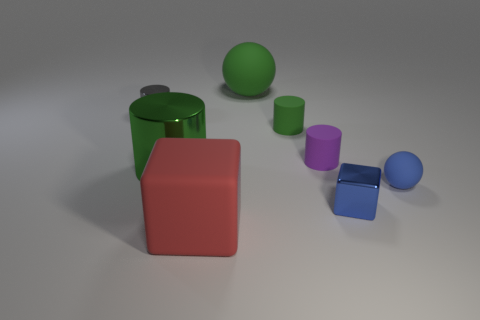Is there any other thing that has the same size as the purple rubber cylinder?
Offer a terse response. Yes. What number of gray objects are tiny metal objects or large cubes?
Make the answer very short. 1. How many green balls are the same size as the green metallic cylinder?
Offer a very short reply. 1. What is the shape of the tiny thing that is the same color as the large metal cylinder?
Provide a succinct answer. Cylinder. What number of objects are small blue rubber cubes or tiny objects on the right side of the big red thing?
Make the answer very short. 4. There is a block that is on the right side of the large green rubber thing; does it have the same size as the ball behind the tiny sphere?
Offer a terse response. No. How many small metallic objects have the same shape as the large shiny object?
Offer a very short reply. 1. The big object that is made of the same material as the tiny gray object is what shape?
Make the answer very short. Cylinder. The small blue thing in front of the tiny sphere to the right of the big green thing that is behind the large shiny thing is made of what material?
Your answer should be very brief. Metal. There is a gray shiny cylinder; is it the same size as the red thing that is in front of the purple matte cylinder?
Your answer should be very brief. No. 